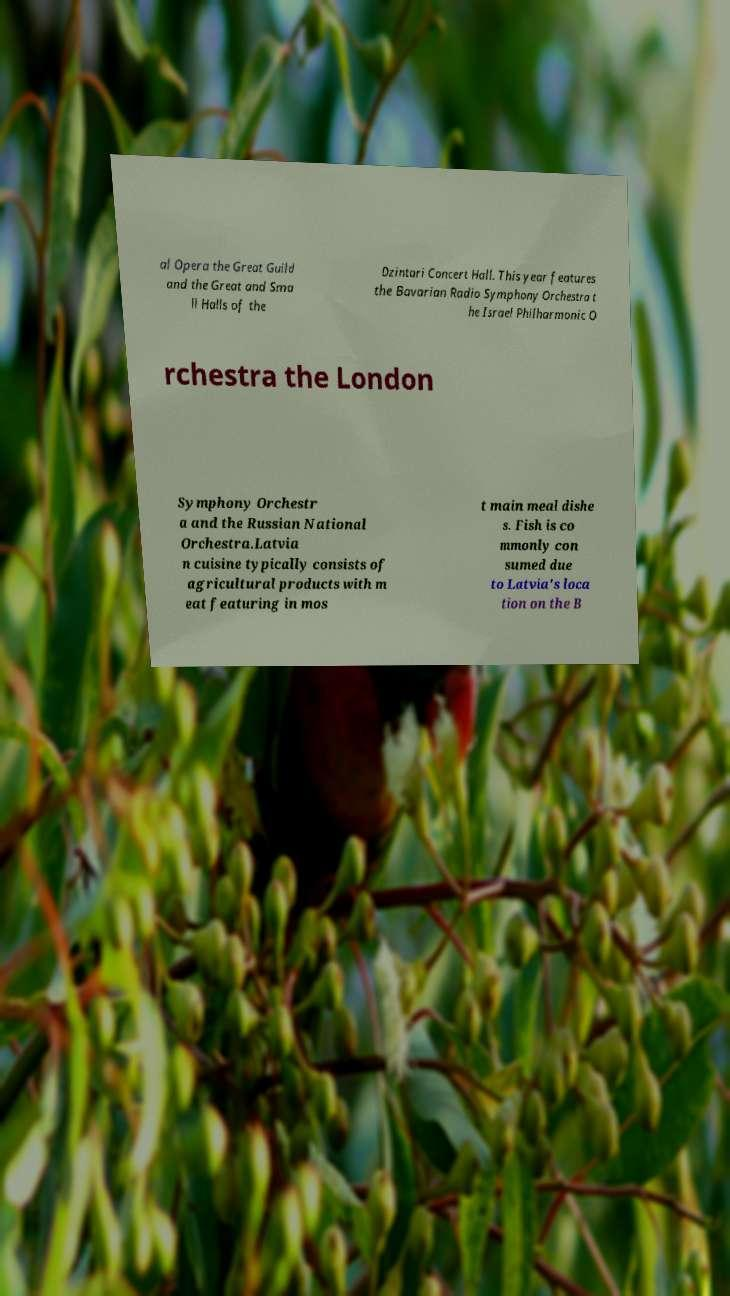There's text embedded in this image that I need extracted. Can you transcribe it verbatim? al Opera the Great Guild and the Great and Sma ll Halls of the Dzintari Concert Hall. This year features the Bavarian Radio Symphony Orchestra t he Israel Philharmonic O rchestra the London Symphony Orchestr a and the Russian National Orchestra.Latvia n cuisine typically consists of agricultural products with m eat featuring in mos t main meal dishe s. Fish is co mmonly con sumed due to Latvia's loca tion on the B 